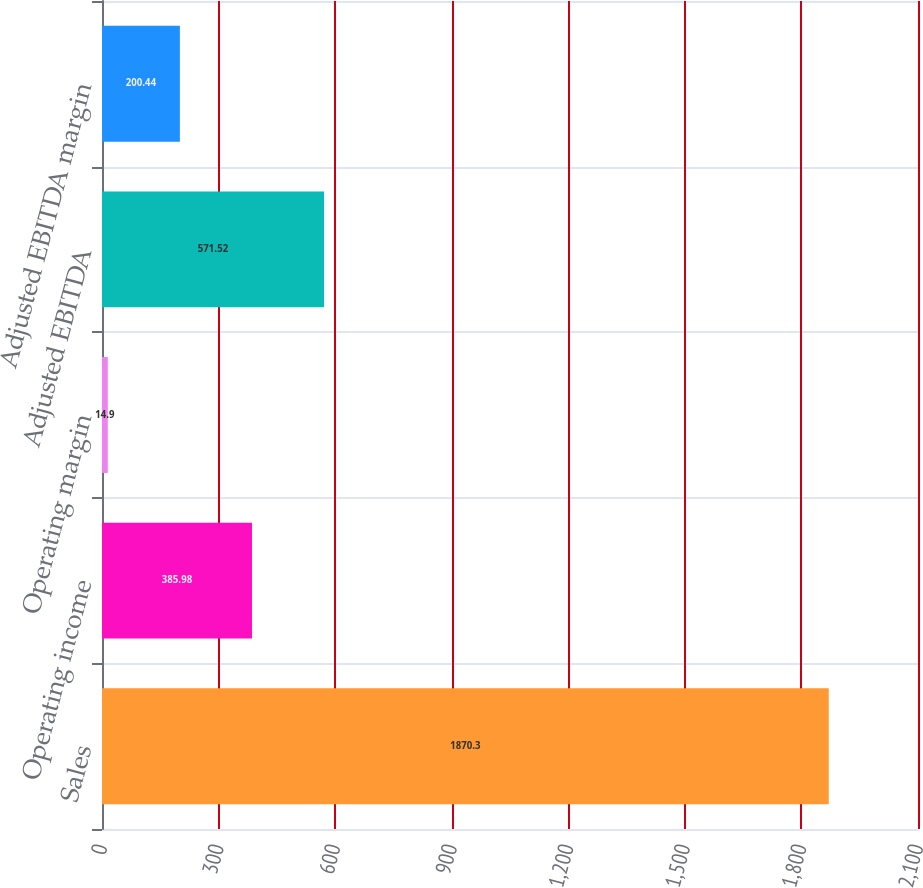<chart> <loc_0><loc_0><loc_500><loc_500><bar_chart><fcel>Sales<fcel>Operating income<fcel>Operating margin<fcel>Adjusted EBITDA<fcel>Adjusted EBITDA margin<nl><fcel>1870.3<fcel>385.98<fcel>14.9<fcel>571.52<fcel>200.44<nl></chart> 